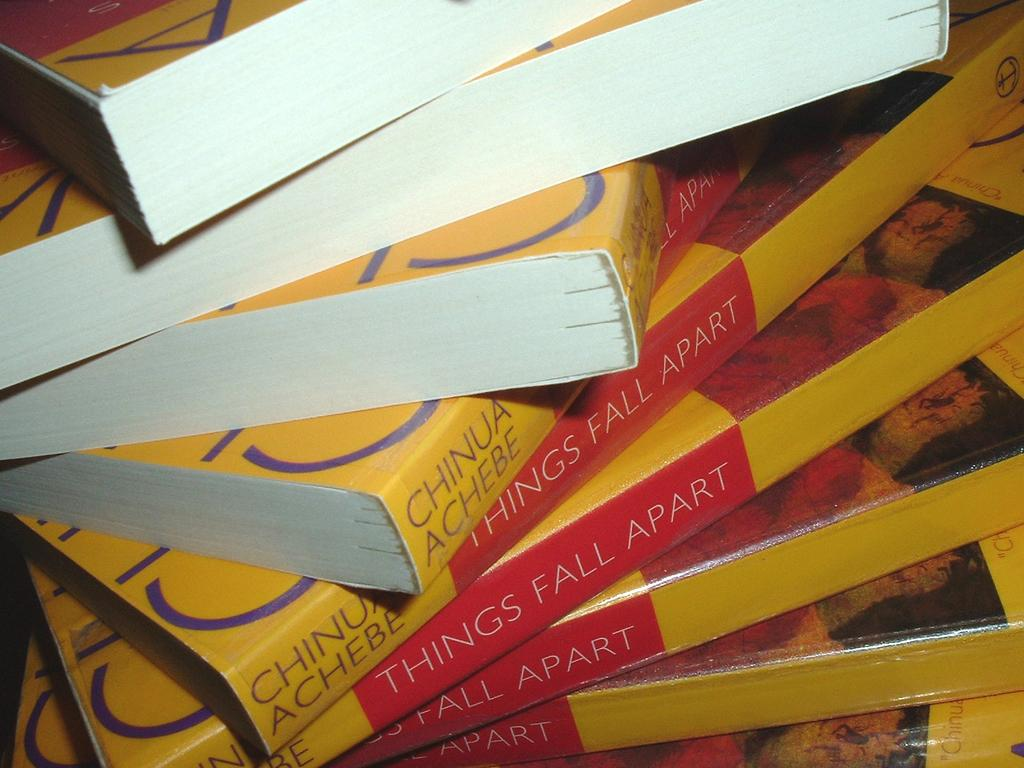<image>
Offer a succinct explanation of the picture presented. A stack of Things Fall Apart books by Chinua Achebe sits on a table. 